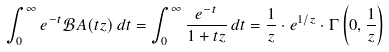Convert formula to latex. <formula><loc_0><loc_0><loc_500><loc_500>\int _ { 0 } ^ { \infty } e ^ { - t } { \mathcal { B } } A ( t z ) \, d t = \int _ { 0 } ^ { \infty } { \frac { e ^ { - t } } { 1 + t z } } \, d t = { \frac { 1 } { z } } \cdot e ^ { 1 / z } \cdot \Gamma \left ( 0 , { \frac { 1 } { z } } \right )</formula> 